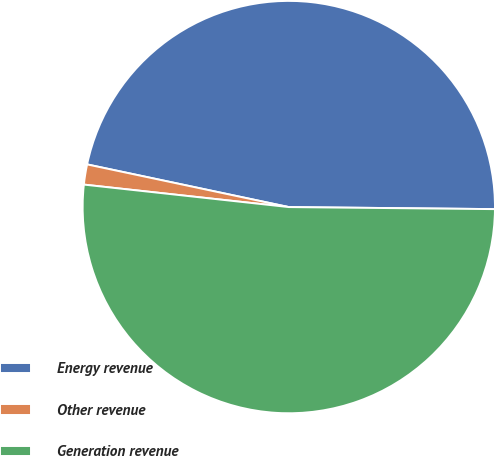Convert chart. <chart><loc_0><loc_0><loc_500><loc_500><pie_chart><fcel>Energy revenue<fcel>Other revenue<fcel>Generation revenue<nl><fcel>46.84%<fcel>1.58%<fcel>51.58%<nl></chart> 